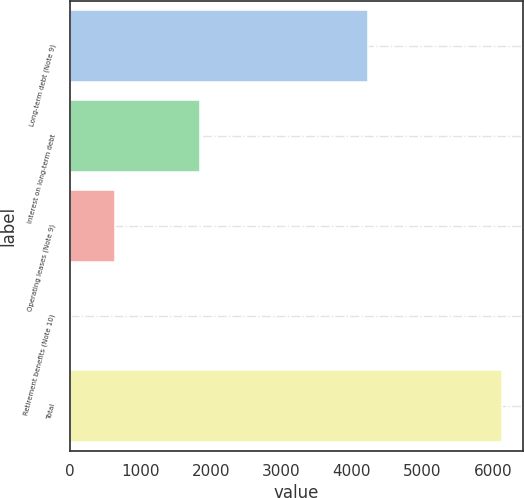Convert chart to OTSL. <chart><loc_0><loc_0><loc_500><loc_500><bar_chart><fcel>Long-term debt (Note 9)<fcel>Interest on long-term debt<fcel>Operating leases (Note 9)<fcel>Retirement benefits (Note 10)<fcel>Total<nl><fcel>4225<fcel>1842<fcel>634.9<fcel>25<fcel>6124<nl></chart> 